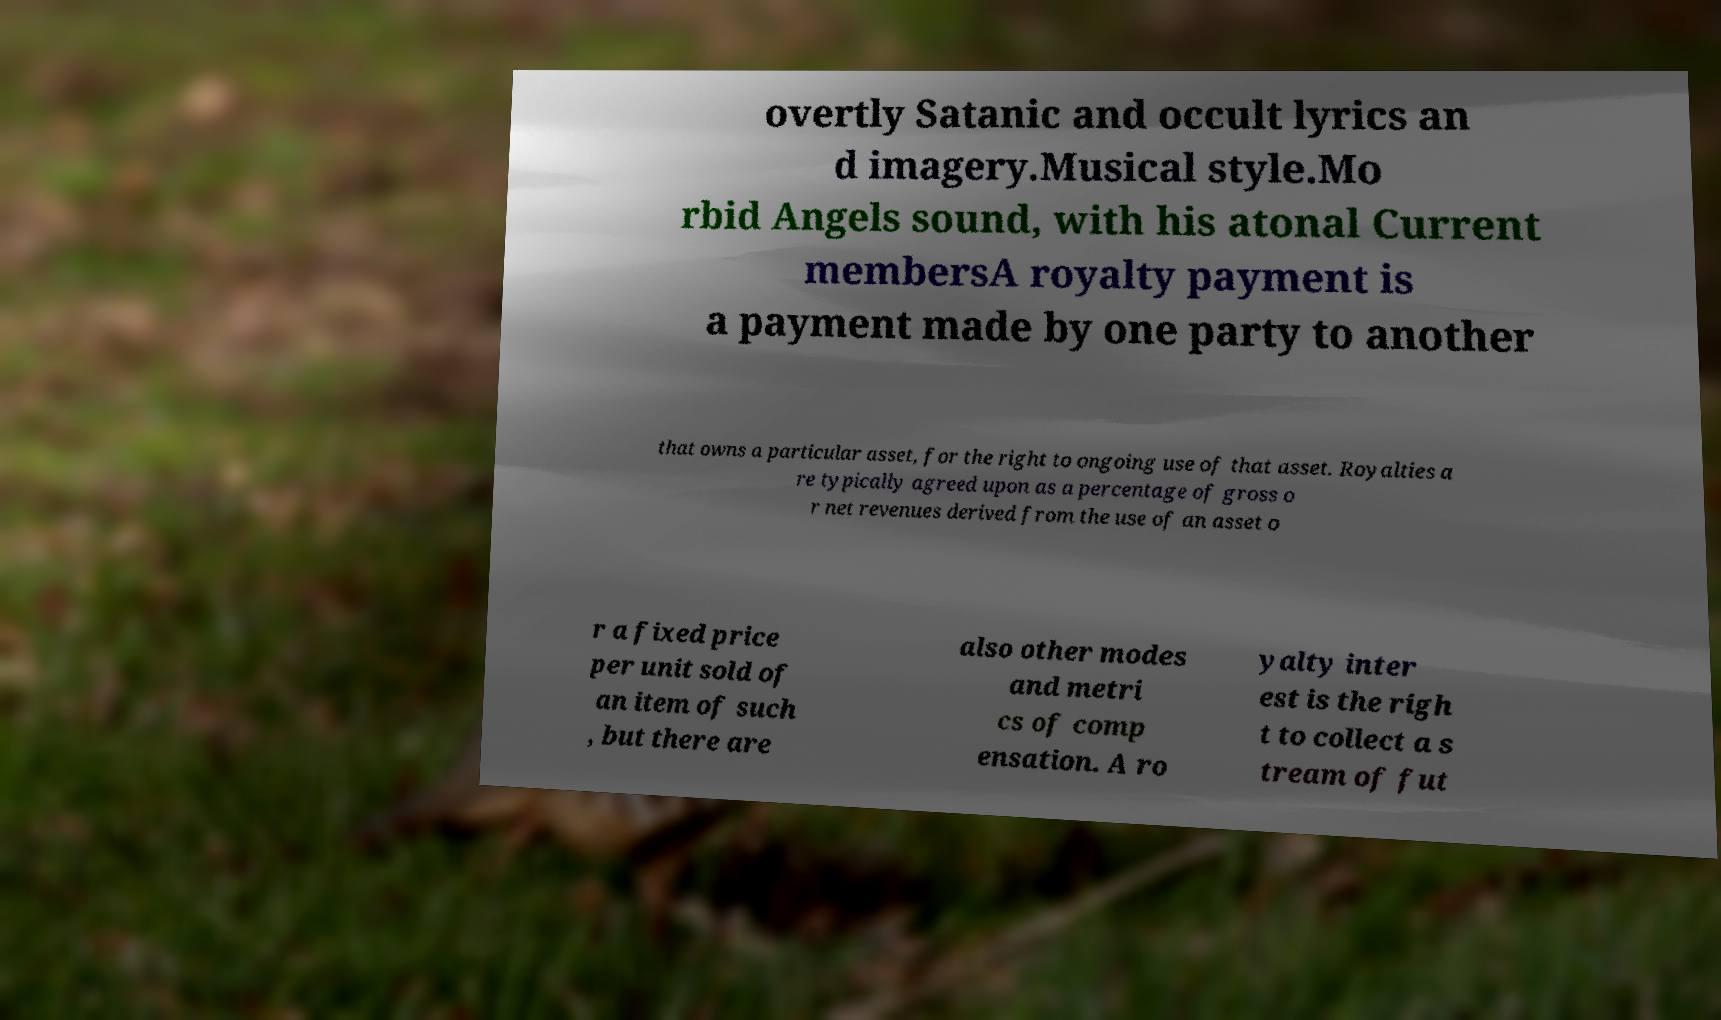What messages or text are displayed in this image? I need them in a readable, typed format. overtly Satanic and occult lyrics an d imagery.Musical style.Mo rbid Angels sound, with his atonal Current membersA royalty payment is a payment made by one party to another that owns a particular asset, for the right to ongoing use of that asset. Royalties a re typically agreed upon as a percentage of gross o r net revenues derived from the use of an asset o r a fixed price per unit sold of an item of such , but there are also other modes and metri cs of comp ensation. A ro yalty inter est is the righ t to collect a s tream of fut 